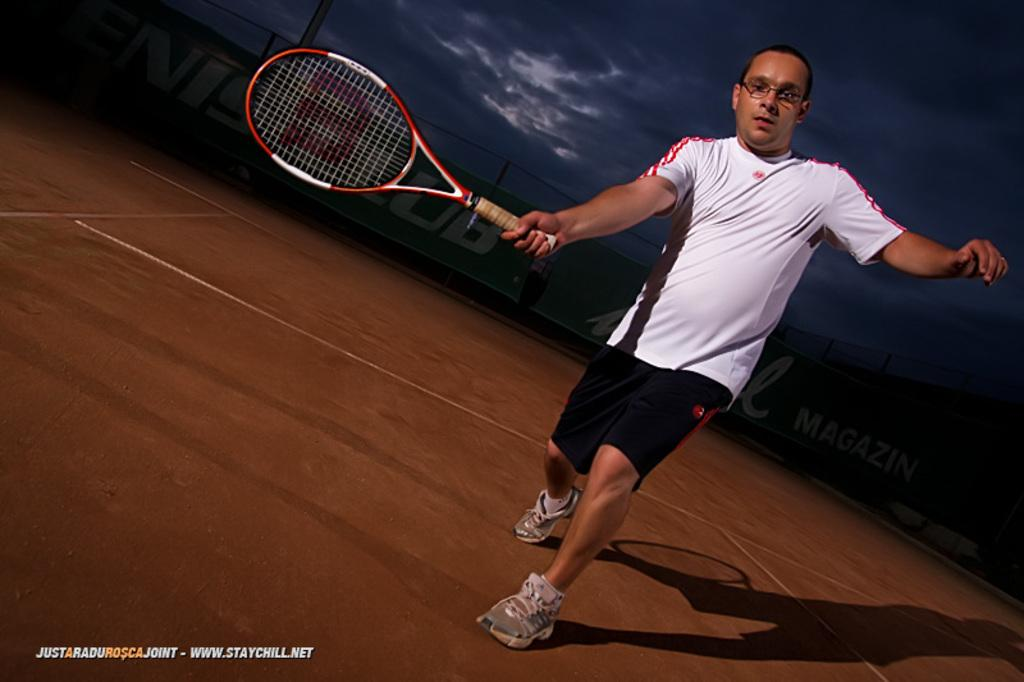What is the person in the image holding? The person is holding a tennis racket. What else can be seen in the image besides the person? There are boards in the image. What is visible in the background of the image? The sky is visible in the image. Is there any additional information about the image itself? Yes, there is a watermark on the image. Where is the flock of birds flying over in the image? There are no birds or flocks visible in the image. 